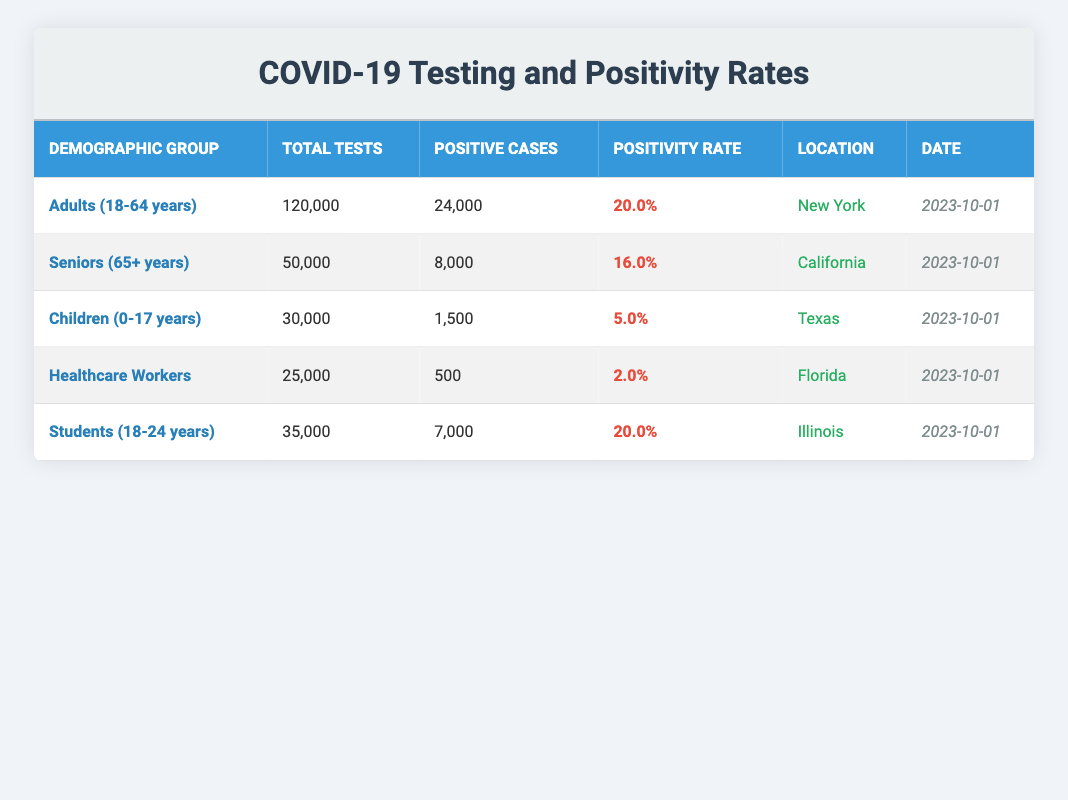What is the positivity rate for Seniors (65+ years) in California? The table lists the positivity rate for Seniors (65+ years) under the "Positivity Rate" column. For California, it is noted as 16.0%.
Answer: 16.0% How many positive cases were reported among Healthcare Workers in Florida? To find the number of positive cases for Healthcare Workers, I refer to the "Positive Cases" column in the respective row for Florida, which indicates there were 500 cases.
Answer: 500 What is the total number of tests conducted for Adults (18-64 years) and Students (18-24 years) combined? First, I identify the total tests for Adults (18-64 years), which is 120,000. Next, I find the total tests for Students (18-24 years), which is 35,000. Adding these values together gives 120,000 + 35,000 = 155,000.
Answer: 155,000 Is the positivity rate for Children (0-17 years) higher than that for Healthcare Workers? The positivity rate for Children (0-17 years) is listed as 5.0%, while for Healthcare Workers it is 2.0%. Since 5.0% is greater than 2.0%, the statement is true.
Answer: Yes What is the average positivity rate across all demographic groups in the table? To calculate the average positivity rate, I first add the individual rates: 20.0% + 16.0% + 5.0% + 2.0% + 20.0% = 63.0%. Then, I divide this sum by the number of groups (5): 63.0% / 5 = 12.6%.
Answer: 12.6% 